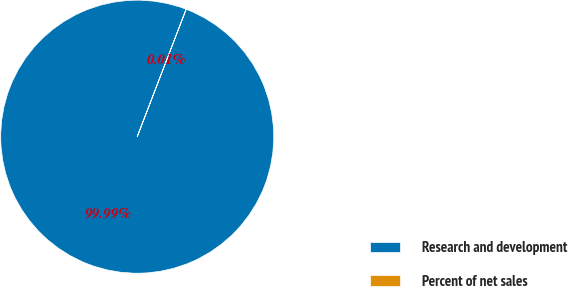Convert chart. <chart><loc_0><loc_0><loc_500><loc_500><pie_chart><fcel>Research and development<fcel>Percent of net sales<nl><fcel>99.99%<fcel>0.01%<nl></chart> 